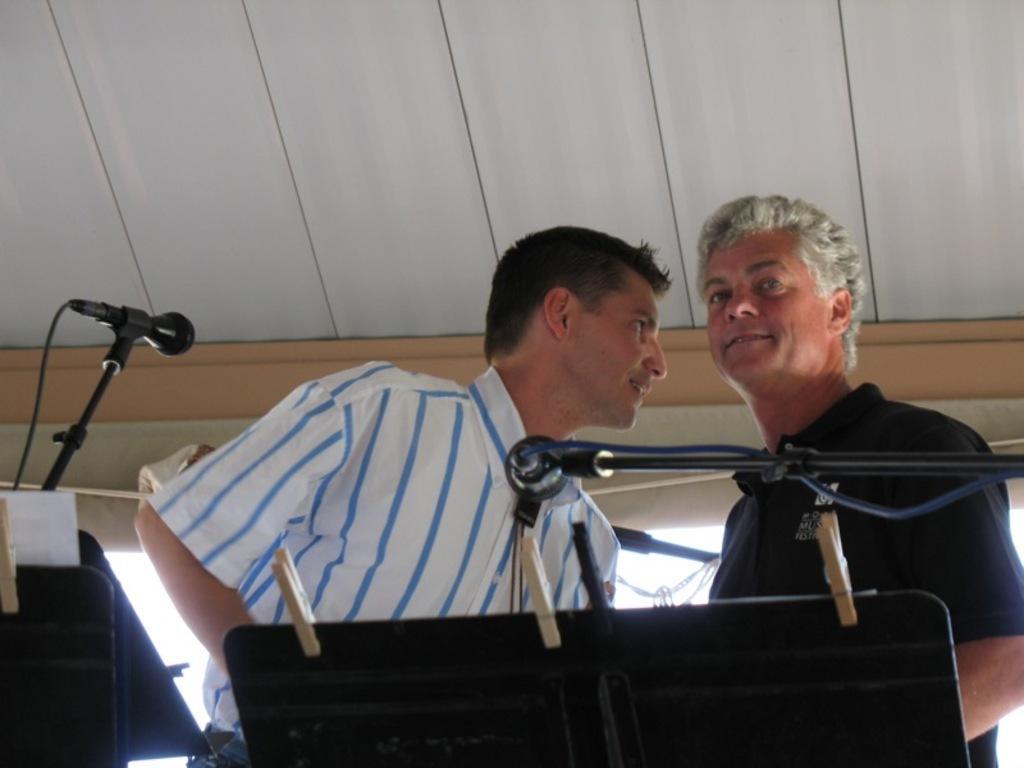How would you summarize this image in a sentence or two? There are two men standing. I think this is a music stand. Here is a mile, which is attached to a mike stand. These are the wooden clips. I think this is another mike stand. On the left side of the image, I can see another music stand with a paper on it. I think this is a kind of a tent. 